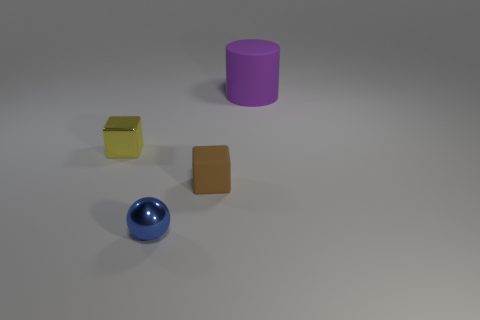Add 4 purple rubber objects. How many objects exist? 8 Subtract 1 cylinders. How many cylinders are left? 0 Subtract 0 gray cylinders. How many objects are left? 4 Subtract all blue cubes. Subtract all gray spheres. How many cubes are left? 2 Subtract all purple cylinders. How many brown cubes are left? 1 Subtract all large red metal cubes. Subtract all yellow objects. How many objects are left? 3 Add 1 blue objects. How many blue objects are left? 2 Add 2 big yellow shiny cylinders. How many big yellow shiny cylinders exist? 2 